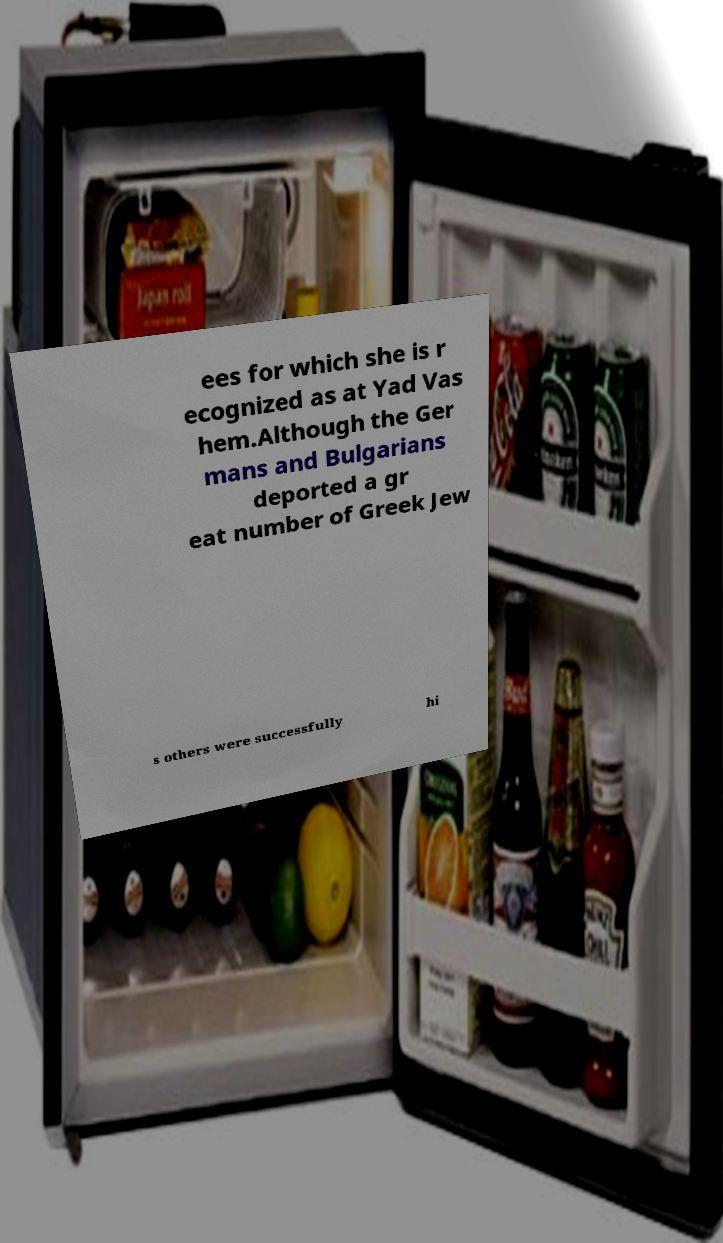Could you assist in decoding the text presented in this image and type it out clearly? ees for which she is r ecognized as at Yad Vas hem.Although the Ger mans and Bulgarians deported a gr eat number of Greek Jew s others were successfully hi 